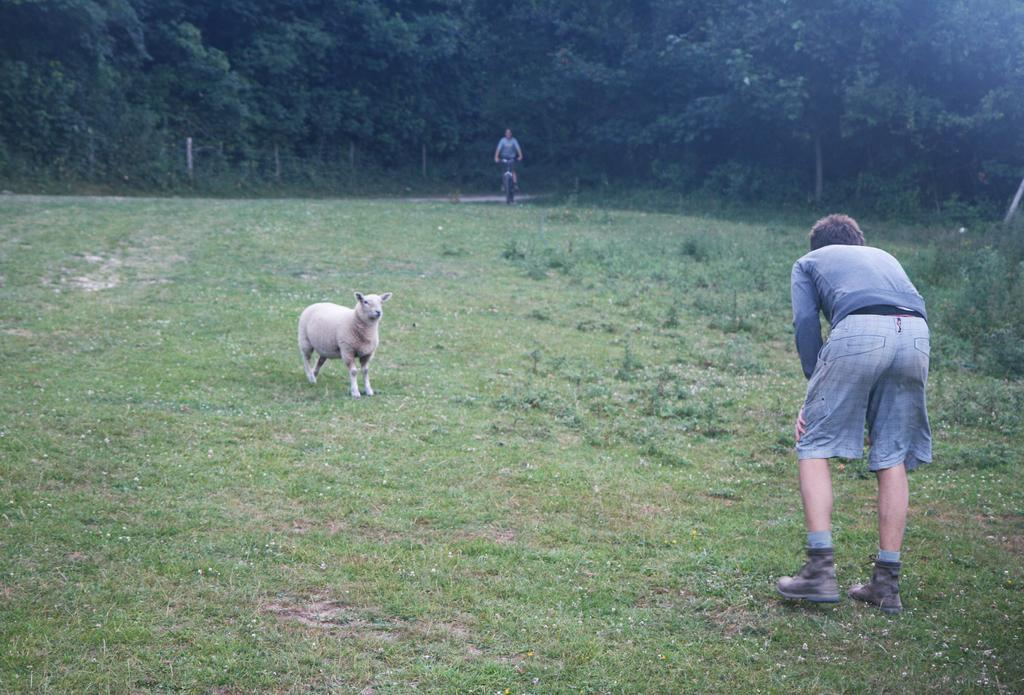What is located in the center of the image? There is a person standing in the center of the image, and there is also an animal in the center of the image. What can be seen in the background of the image? There are trees, plants, grass, poles, and a person riding a cycle in the background of the image. What type of corn can be seen growing in the image? There is no corn present in the image; the background features trees, plants, grass, poles, and a person riding a cycle. 